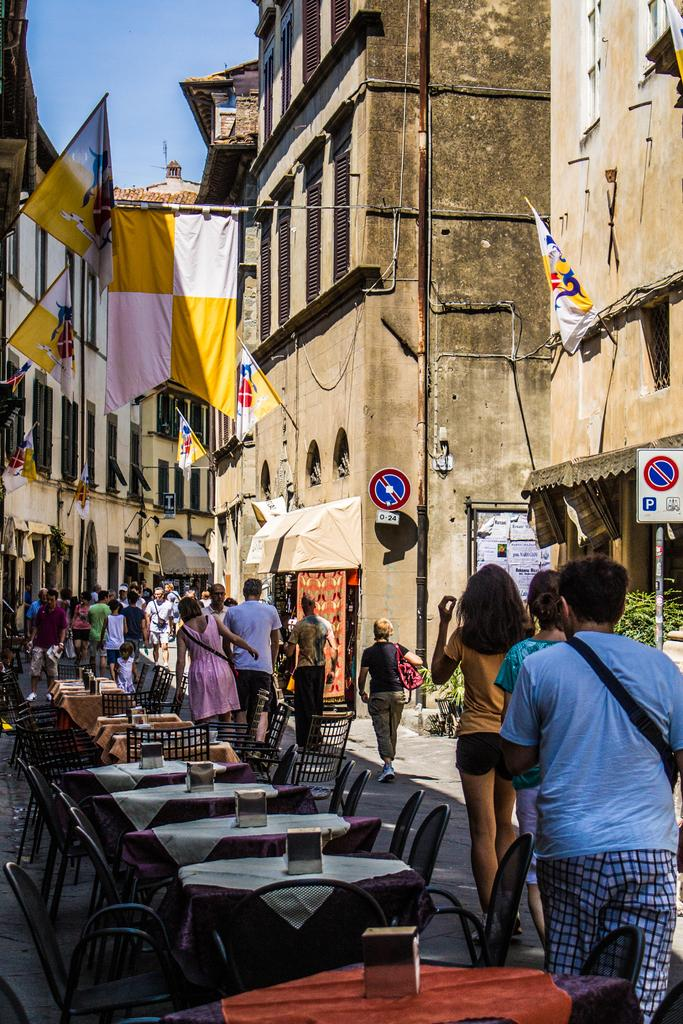What are the people in the image doing? The people in the image are walking on the road. What furniture arrangement can be seen on the left side of the image? There is a table and chair arrangement on the left side of the image. What decorative elements are visible in the image? Flags are visible in the image. What type of structures can be seen in the image? There are buildings in the image. What type of soup is being served at the table in the image? There is no table or soup present in the image; it only shows people walking on the road and flags. 